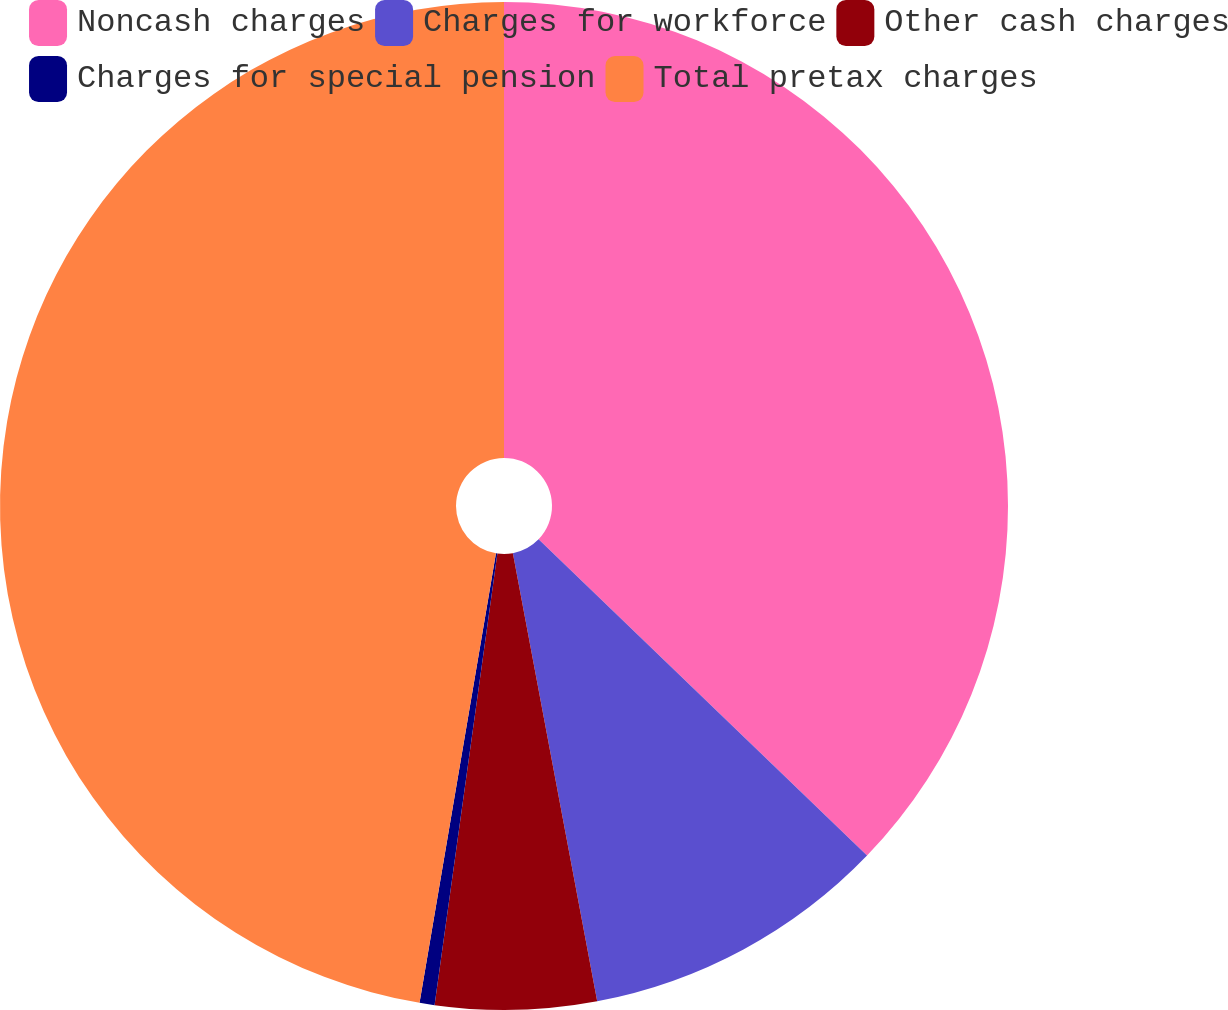<chart> <loc_0><loc_0><loc_500><loc_500><pie_chart><fcel>Noncash charges<fcel>Charges for workforce<fcel>Other cash charges<fcel>Charges for special pension<fcel>Total pretax charges<nl><fcel>37.2%<fcel>9.84%<fcel>5.16%<fcel>0.48%<fcel>47.32%<nl></chart> 